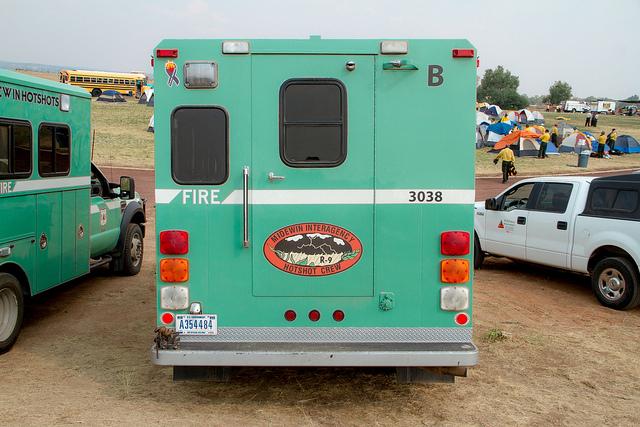Is this a milk truck?
Give a very brief answer. No. Is there a yellow school bus?
Answer briefly. Yes. Is anyone camping out?
Answer briefly. Yes. 